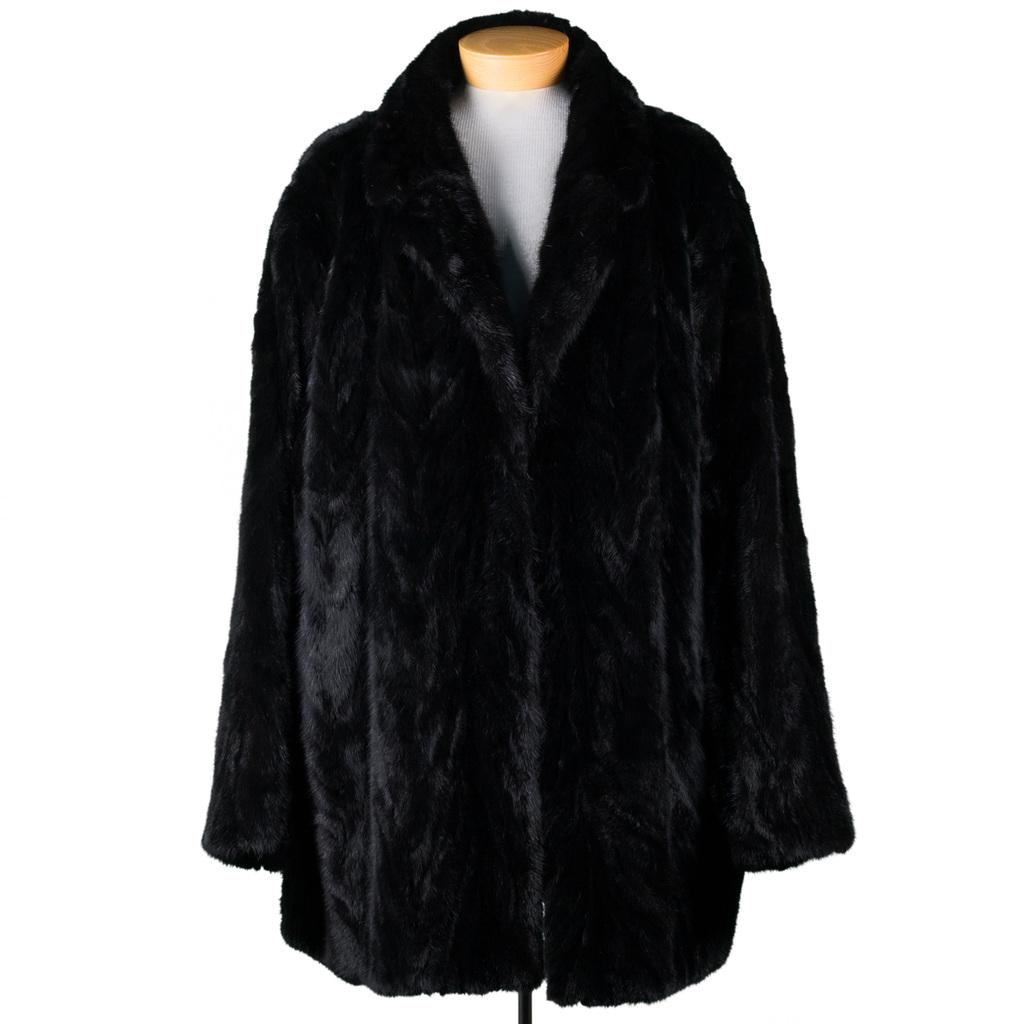What color is the jacket in the image? The jacket in the image is black. What is the jacket placed on? The jacket is placed on a white color thing. What is the overall color scheme of the image? The background of the image is white. How many dogs are visible in the image? There are no dogs present in the image. What type of vegetable is being used as a base for the jacket in the image? There is no vegetable being used as a base for the jacket in the image; it is simply placed on a white color thing. 